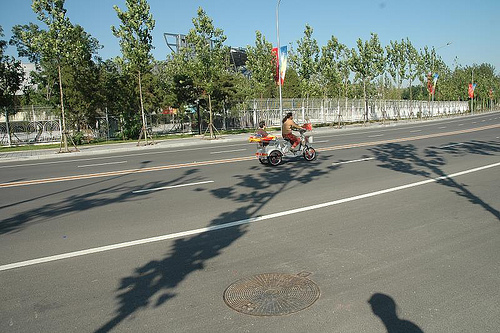<image>
Is there a manhole cover behind the tricycle? Yes. From this viewpoint, the manhole cover is positioned behind the tricycle, with the tricycle partially or fully occluding the manhole cover. Is there a sewer in front of the road? No. The sewer is not in front of the road. The spatial positioning shows a different relationship between these objects. 